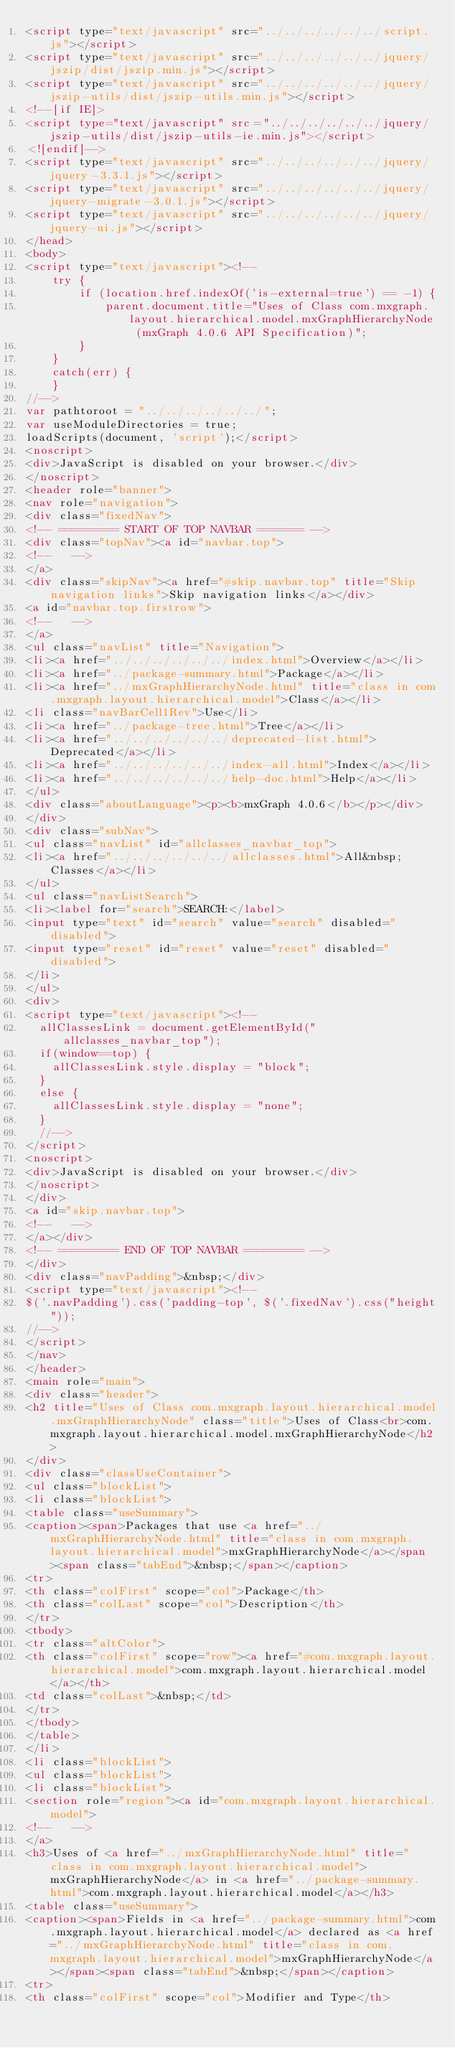Convert code to text. <code><loc_0><loc_0><loc_500><loc_500><_HTML_><script type="text/javascript" src="../../../../../../script.js"></script>
<script type="text/javascript" src="../../../../../../jquery/jszip/dist/jszip.min.js"></script>
<script type="text/javascript" src="../../../../../../jquery/jszip-utils/dist/jszip-utils.min.js"></script>
<!--[if IE]>
<script type="text/javascript" src="../../../../../../jquery/jszip-utils/dist/jszip-utils-ie.min.js"></script>
<![endif]-->
<script type="text/javascript" src="../../../../../../jquery/jquery-3.3.1.js"></script>
<script type="text/javascript" src="../../../../../../jquery/jquery-migrate-3.0.1.js"></script>
<script type="text/javascript" src="../../../../../../jquery/jquery-ui.js"></script>
</head>
<body>
<script type="text/javascript"><!--
    try {
        if (location.href.indexOf('is-external=true') == -1) {
            parent.document.title="Uses of Class com.mxgraph.layout.hierarchical.model.mxGraphHierarchyNode (mxGraph 4.0.6 API Specification)";
        }
    }
    catch(err) {
    }
//-->
var pathtoroot = "../../../../../../";
var useModuleDirectories = true;
loadScripts(document, 'script');</script>
<noscript>
<div>JavaScript is disabled on your browser.</div>
</noscript>
<header role="banner">
<nav role="navigation">
<div class="fixedNav">
<!-- ========= START OF TOP NAVBAR ======= -->
<div class="topNav"><a id="navbar.top">
<!--   -->
</a>
<div class="skipNav"><a href="#skip.navbar.top" title="Skip navigation links">Skip navigation links</a></div>
<a id="navbar.top.firstrow">
<!--   -->
</a>
<ul class="navList" title="Navigation">
<li><a href="../../../../../../index.html">Overview</a></li>
<li><a href="../package-summary.html">Package</a></li>
<li><a href="../mxGraphHierarchyNode.html" title="class in com.mxgraph.layout.hierarchical.model">Class</a></li>
<li class="navBarCell1Rev">Use</li>
<li><a href="../package-tree.html">Tree</a></li>
<li><a href="../../../../../../deprecated-list.html">Deprecated</a></li>
<li><a href="../../../../../../index-all.html">Index</a></li>
<li><a href="../../../../../../help-doc.html">Help</a></li>
</ul>
<div class="aboutLanguage"><p><b>mxGraph 4.0.6</b></p></div>
</div>
<div class="subNav">
<ul class="navList" id="allclasses_navbar_top">
<li><a href="../../../../../../allclasses.html">All&nbsp;Classes</a></li>
</ul>
<ul class="navListSearch">
<li><label for="search">SEARCH:</label>
<input type="text" id="search" value="search" disabled="disabled">
<input type="reset" id="reset" value="reset" disabled="disabled">
</li>
</ul>
<div>
<script type="text/javascript"><!--
  allClassesLink = document.getElementById("allclasses_navbar_top");
  if(window==top) {
    allClassesLink.style.display = "block";
  }
  else {
    allClassesLink.style.display = "none";
  }
  //-->
</script>
<noscript>
<div>JavaScript is disabled on your browser.</div>
</noscript>
</div>
<a id="skip.navbar.top">
<!--   -->
</a></div>
<!-- ========= END OF TOP NAVBAR ========= -->
</div>
<div class="navPadding">&nbsp;</div>
<script type="text/javascript"><!--
$('.navPadding').css('padding-top', $('.fixedNav').css("height"));
//-->
</script>
</nav>
</header>
<main role="main">
<div class="header">
<h2 title="Uses of Class com.mxgraph.layout.hierarchical.model.mxGraphHierarchyNode" class="title">Uses of Class<br>com.mxgraph.layout.hierarchical.model.mxGraphHierarchyNode</h2>
</div>
<div class="classUseContainer">
<ul class="blockList">
<li class="blockList">
<table class="useSummary">
<caption><span>Packages that use <a href="../mxGraphHierarchyNode.html" title="class in com.mxgraph.layout.hierarchical.model">mxGraphHierarchyNode</a></span><span class="tabEnd">&nbsp;</span></caption>
<tr>
<th class="colFirst" scope="col">Package</th>
<th class="colLast" scope="col">Description</th>
</tr>
<tbody>
<tr class="altColor">
<th class="colFirst" scope="row"><a href="#com.mxgraph.layout.hierarchical.model">com.mxgraph.layout.hierarchical.model</a></th>
<td class="colLast">&nbsp;</td>
</tr>
</tbody>
</table>
</li>
<li class="blockList">
<ul class="blockList">
<li class="blockList">
<section role="region"><a id="com.mxgraph.layout.hierarchical.model">
<!--   -->
</a>
<h3>Uses of <a href="../mxGraphHierarchyNode.html" title="class in com.mxgraph.layout.hierarchical.model">mxGraphHierarchyNode</a> in <a href="../package-summary.html">com.mxgraph.layout.hierarchical.model</a></h3>
<table class="useSummary">
<caption><span>Fields in <a href="../package-summary.html">com.mxgraph.layout.hierarchical.model</a> declared as <a href="../mxGraphHierarchyNode.html" title="class in com.mxgraph.layout.hierarchical.model">mxGraphHierarchyNode</a></span><span class="tabEnd">&nbsp;</span></caption>
<tr>
<th class="colFirst" scope="col">Modifier and Type</th></code> 